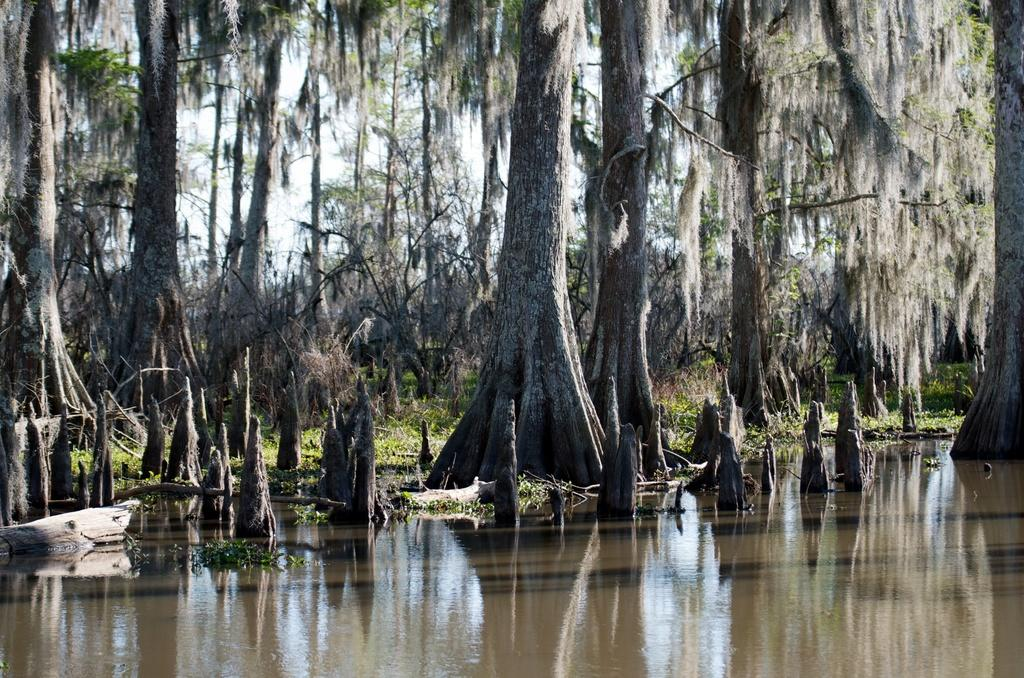What is the primary element present in the image? There is water in the image. What other natural elements can be seen in the image? There are plants and trees in the image. What can be seen in the background of the image? The sky is visible in the background of the image. What type of iron is being used to water the plants in the image? There is no iron present in the image, and the plants do not appear to be watered. 